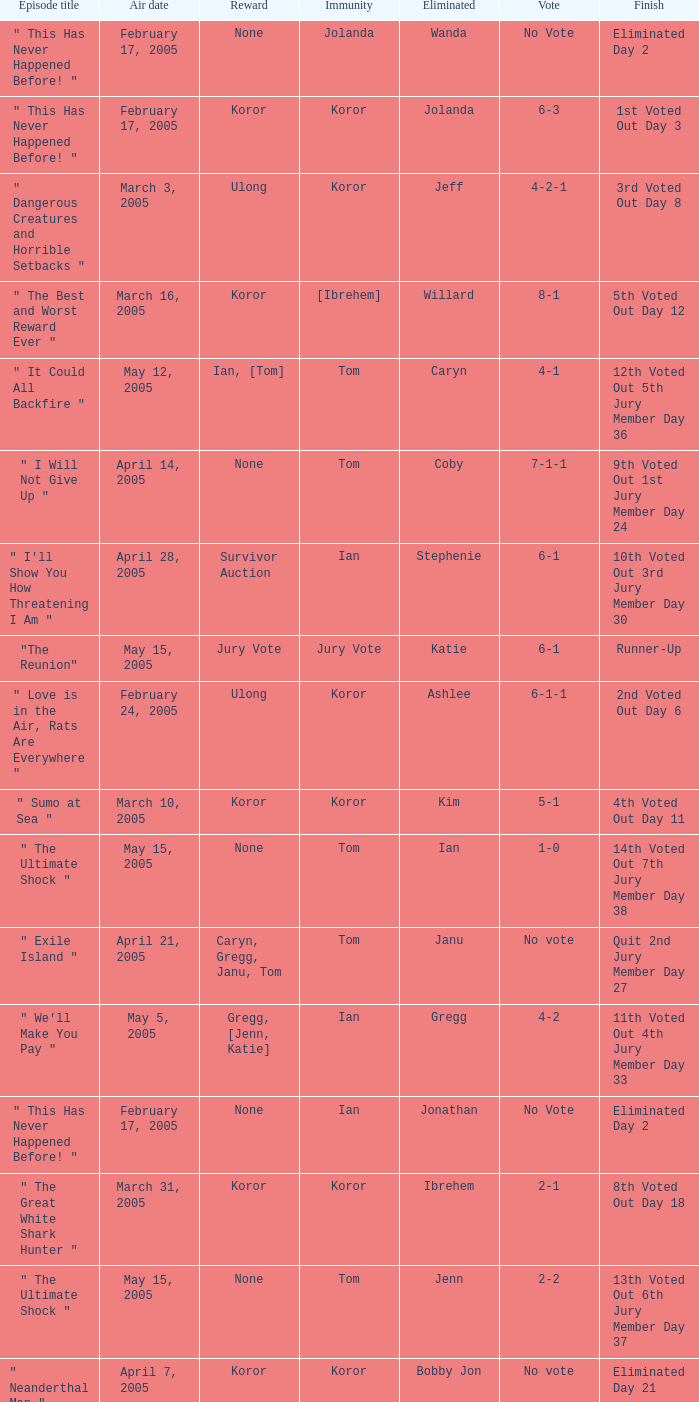How many persons had immunity in the episode when Wanda was eliminated? 1.0. 